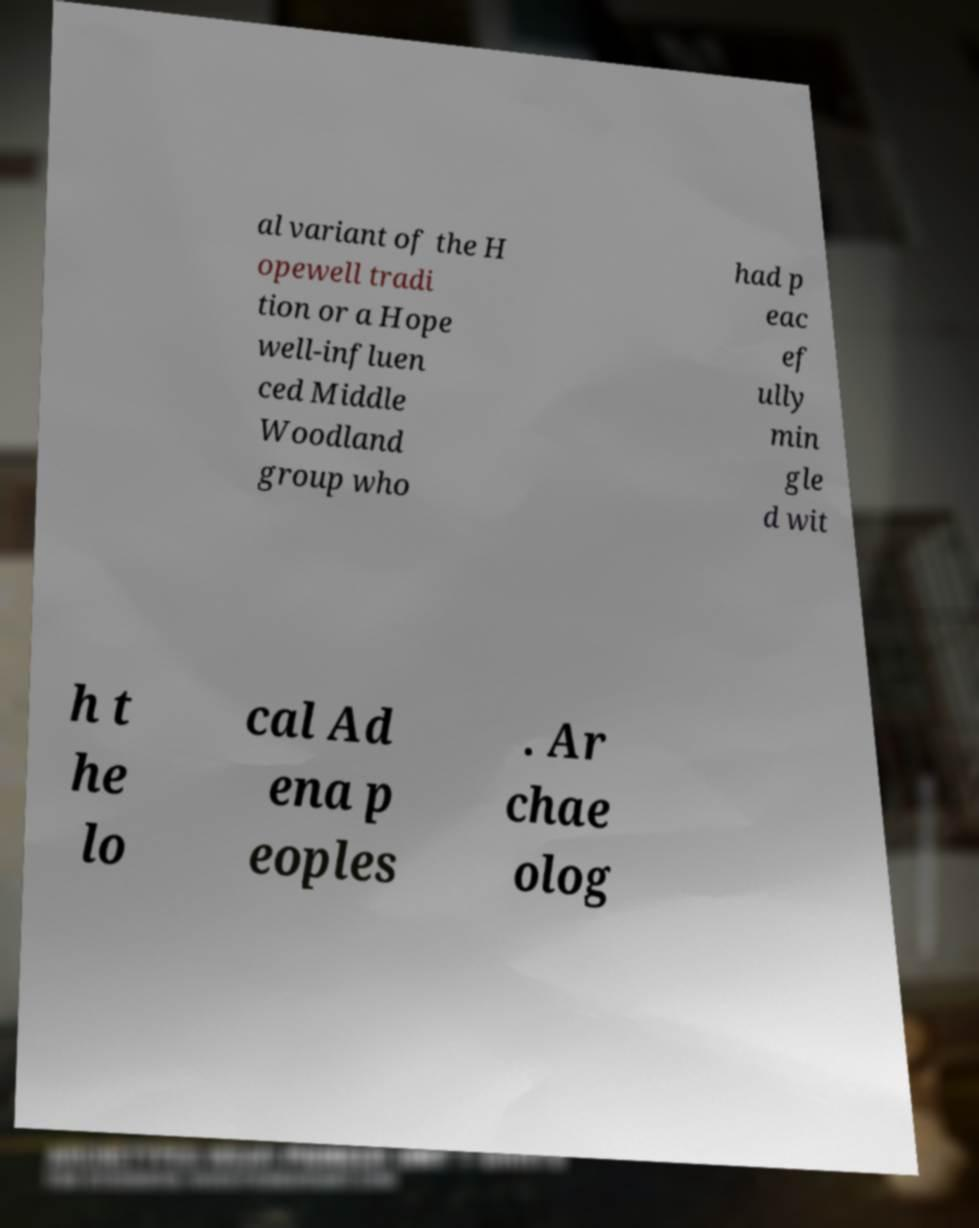I need the written content from this picture converted into text. Can you do that? al variant of the H opewell tradi tion or a Hope well-influen ced Middle Woodland group who had p eac ef ully min gle d wit h t he lo cal Ad ena p eoples . Ar chae olog 